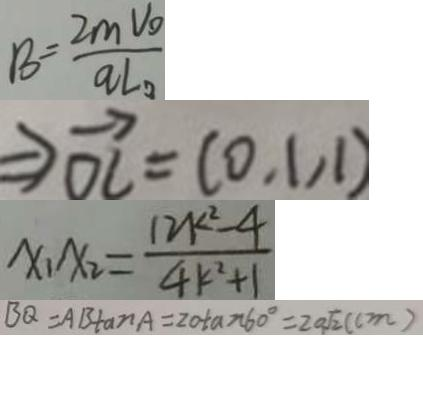<formula> <loc_0><loc_0><loc_500><loc_500>B = \frac { 2 m v _ { o } } { q L _ { 0 } . } 
 \rightarrow \overrightarrow { O C } = ( 0 . 1 , 1 ) 
 x _ { 1 } x _ { 2 } = \frac { 1 2 k ^ { 2 } - 4 } { 4 k ^ { 2 } + 1 } 
 B Q = A B \tan A = 2 0 / \tan 6 0 ^ { \circ } = 2 0 \sqrt { 2 } ( c m )</formula> 